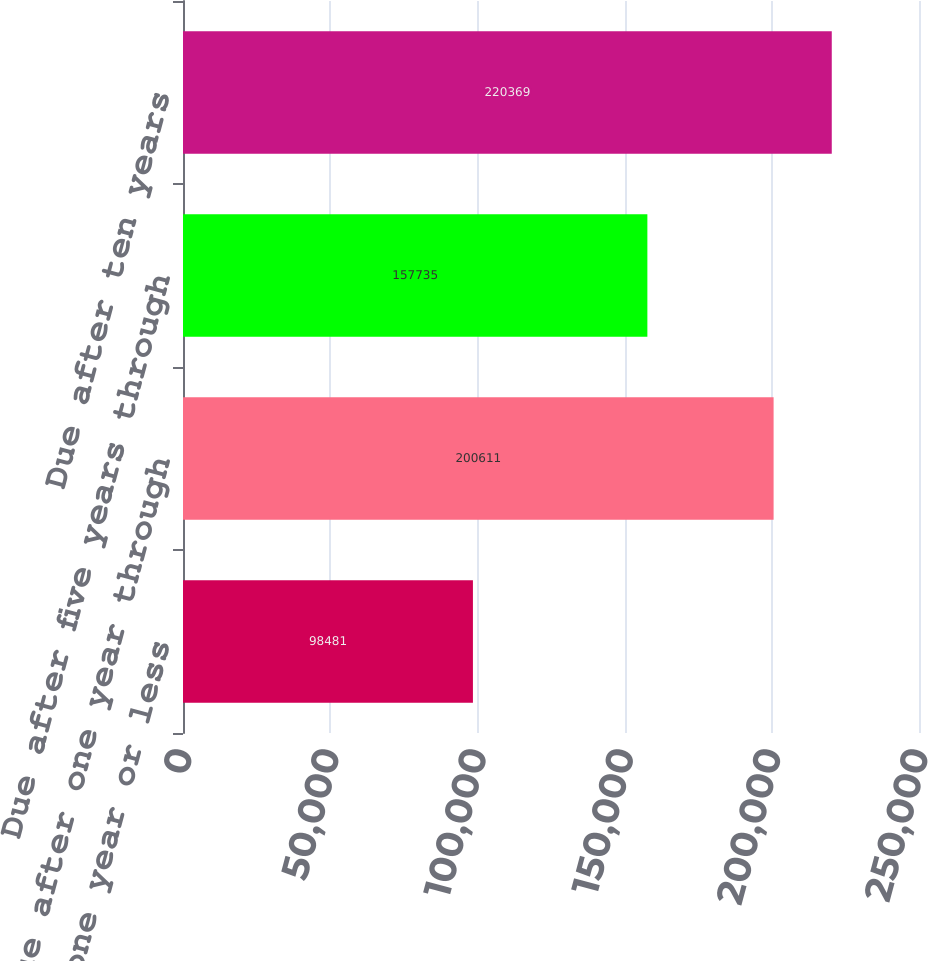Convert chart. <chart><loc_0><loc_0><loc_500><loc_500><bar_chart><fcel>Due in one year or less<fcel>Due after one year through<fcel>Due after five years through<fcel>Due after ten years<nl><fcel>98481<fcel>200611<fcel>157735<fcel>220369<nl></chart> 